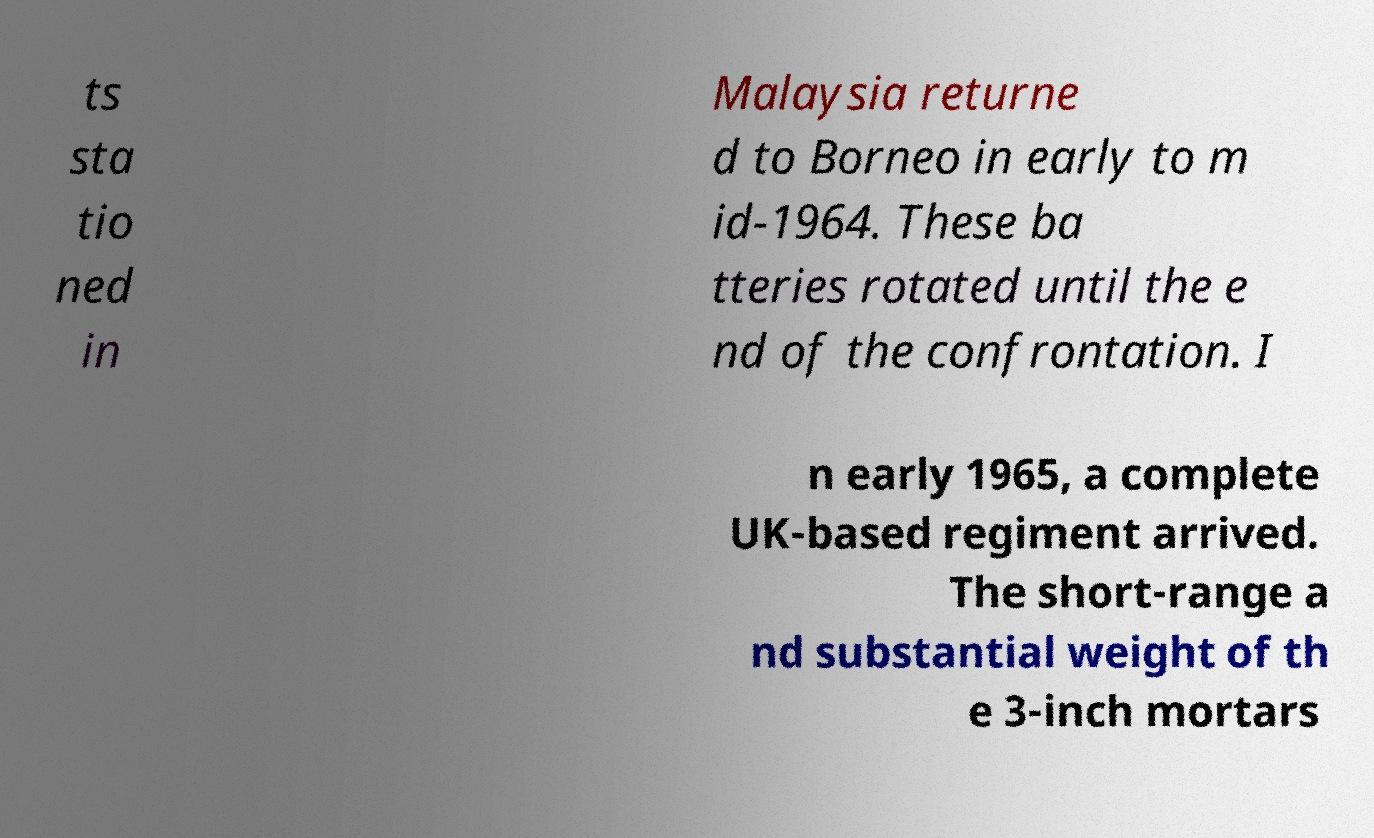Could you extract and type out the text from this image? ts sta tio ned in Malaysia returne d to Borneo in early to m id-1964. These ba tteries rotated until the e nd of the confrontation. I n early 1965, a complete UK-based regiment arrived. The short-range a nd substantial weight of th e 3-inch mortars 